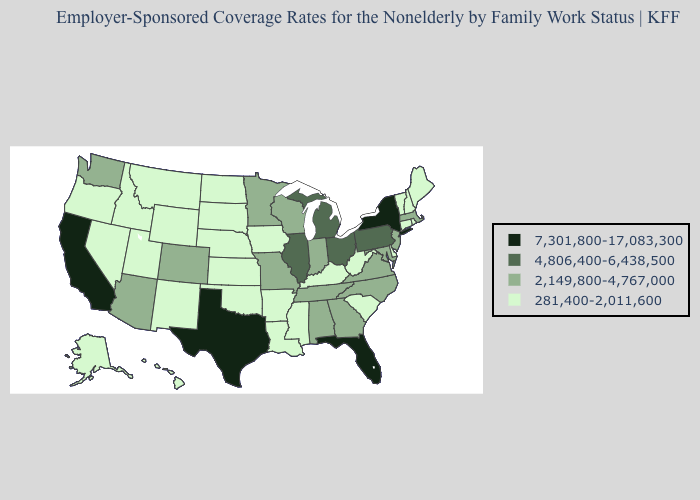Name the states that have a value in the range 4,806,400-6,438,500?
Write a very short answer. Illinois, Michigan, Ohio, Pennsylvania. What is the value of Nebraska?
Quick response, please. 281,400-2,011,600. What is the value of Arkansas?
Write a very short answer. 281,400-2,011,600. Does Wisconsin have the lowest value in the USA?
Give a very brief answer. No. Does the map have missing data?
Answer briefly. No. Does the map have missing data?
Short answer required. No. Which states have the highest value in the USA?
Concise answer only. California, Florida, New York, Texas. What is the value of Rhode Island?
Write a very short answer. 281,400-2,011,600. Name the states that have a value in the range 7,301,800-17,083,300?
Keep it brief. California, Florida, New York, Texas. What is the lowest value in the USA?
Concise answer only. 281,400-2,011,600. What is the value of Oklahoma?
Quick response, please. 281,400-2,011,600. Does the first symbol in the legend represent the smallest category?
Keep it brief. No. Name the states that have a value in the range 7,301,800-17,083,300?
Be succinct. California, Florida, New York, Texas. What is the highest value in the MidWest ?
Keep it brief. 4,806,400-6,438,500. 